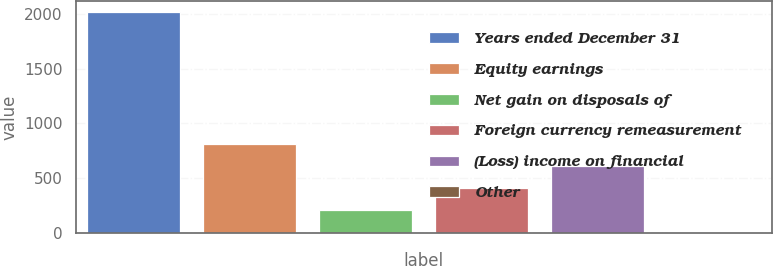Convert chart. <chart><loc_0><loc_0><loc_500><loc_500><bar_chart><fcel>Years ended December 31<fcel>Equity earnings<fcel>Net gain on disposals of<fcel>Foreign currency remeasurement<fcel>(Loss) income on financial<fcel>Other<nl><fcel>2013<fcel>809.4<fcel>207.6<fcel>408.2<fcel>608.8<fcel>7<nl></chart> 